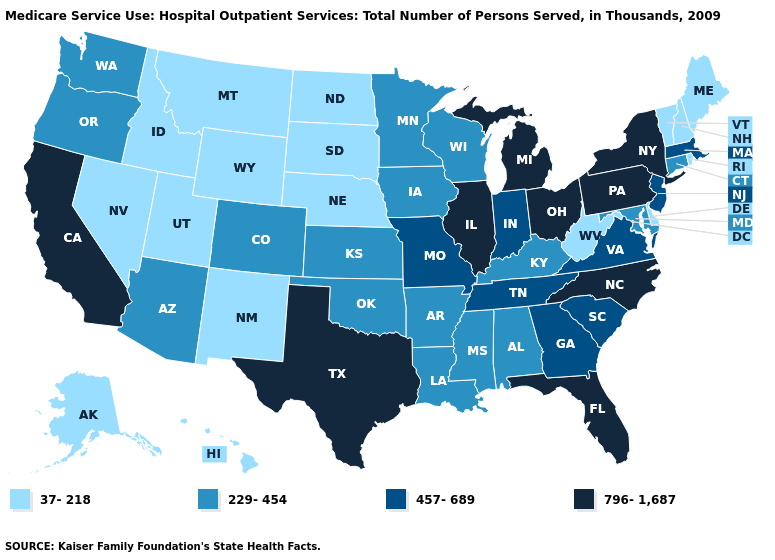What is the value of Massachusetts?
Quick response, please. 457-689. What is the highest value in states that border South Dakota?
Be succinct. 229-454. Which states have the lowest value in the USA?
Keep it brief. Alaska, Delaware, Hawaii, Idaho, Maine, Montana, Nebraska, Nevada, New Hampshire, New Mexico, North Dakota, Rhode Island, South Dakota, Utah, Vermont, West Virginia, Wyoming. What is the highest value in the USA?
Quick response, please. 796-1,687. Name the states that have a value in the range 37-218?
Keep it brief. Alaska, Delaware, Hawaii, Idaho, Maine, Montana, Nebraska, Nevada, New Hampshire, New Mexico, North Dakota, Rhode Island, South Dakota, Utah, Vermont, West Virginia, Wyoming. Among the states that border North Dakota , which have the highest value?
Answer briefly. Minnesota. What is the value of California?
Be succinct. 796-1,687. Is the legend a continuous bar?
Quick response, please. No. Name the states that have a value in the range 229-454?
Quick response, please. Alabama, Arizona, Arkansas, Colorado, Connecticut, Iowa, Kansas, Kentucky, Louisiana, Maryland, Minnesota, Mississippi, Oklahoma, Oregon, Washington, Wisconsin. What is the highest value in states that border Alabama?
Keep it brief. 796-1,687. Which states have the highest value in the USA?
Quick response, please. California, Florida, Illinois, Michigan, New York, North Carolina, Ohio, Pennsylvania, Texas. Name the states that have a value in the range 229-454?
Short answer required. Alabama, Arizona, Arkansas, Colorado, Connecticut, Iowa, Kansas, Kentucky, Louisiana, Maryland, Minnesota, Mississippi, Oklahoma, Oregon, Washington, Wisconsin. Among the states that border Texas , does New Mexico have the lowest value?
Write a very short answer. Yes. How many symbols are there in the legend?
Give a very brief answer. 4. Does Colorado have the lowest value in the USA?
Give a very brief answer. No. 